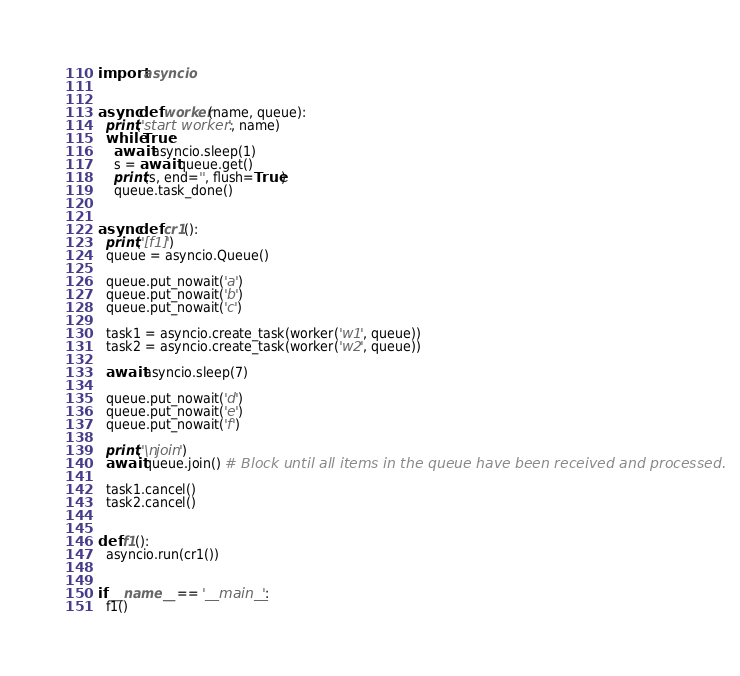Convert code to text. <code><loc_0><loc_0><loc_500><loc_500><_Python_>import asyncio


async def worker(name, queue):
  print('start worker: ', name)
  while True:
    await asyncio.sleep(1)
    s = await queue.get()
    print(s, end='', flush=True)
    queue.task_done()


async def cr1():
  print('[f1]')
  queue = asyncio.Queue()

  queue.put_nowait('a')
  queue.put_nowait('b')
  queue.put_nowait('c')

  task1 = asyncio.create_task(worker('w1', queue))
  task2 = asyncio.create_task(worker('w2', queue))

  await asyncio.sleep(7)

  queue.put_nowait('d')
  queue.put_nowait('e')
  queue.put_nowait('f')

  print('\njoin')
  await queue.join() # Block until all items in the queue have been received and processed.

  task1.cancel()
  task2.cancel()


def f1():
  asyncio.run(cr1())


if __name__ == '__main__':
  f1()
</code> 